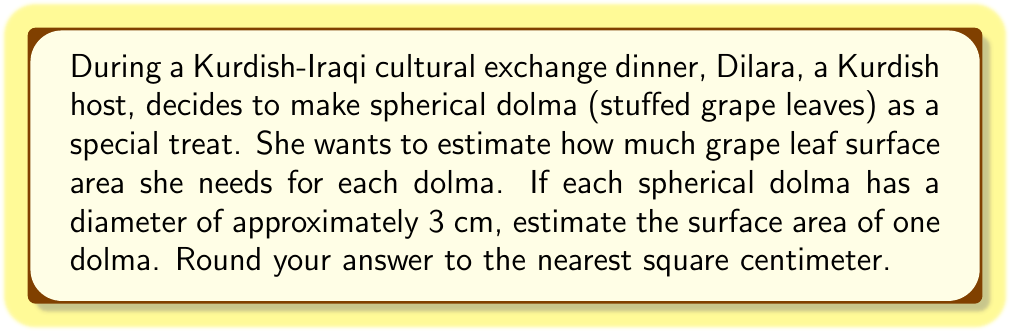Solve this math problem. To solve this problem, we need to use the formula for the surface area of a sphere:

$$A = 4\pi r^2$$

Where:
$A$ is the surface area
$r$ is the radius of the sphere

Given information:
- Diameter of the dolma = 3 cm
- Radius = Diameter ÷ 2 = 3 cm ÷ 2 = 1.5 cm

Steps to solve:

1. Calculate the surface area using the formula:
   $$A = 4\pi (1.5\text{ cm})^2$$

2. Simplify:
   $$A = 4\pi (2.25\text{ cm}^2)$$
   $$A = 9\pi\text{ cm}^2$$

3. Calculate the value (π ≈ 3.14159):
   $$A \approx 9 \times 3.14159\text{ cm}^2$$
   $$A \approx 28.27431\text{ cm}^2$$

4. Round to the nearest square centimeter:
   $$A \approx 28\text{ cm}^2$$

Therefore, the estimated surface area of one spherical dolma is approximately 28 square centimeters.

[asy]
import geometry;

size(100);
draw(circle((0,0),1), blue);
draw((0,0)--(1,0), arrow=Arrow(TeXHead));
label("1.5 cm", (0.5,0), S);
label("3 cm", (0,-1.2));
draw((-1.5,0)--(1.5,0), dashed);
[/asy]
Answer: $28\text{ cm}^2$ 